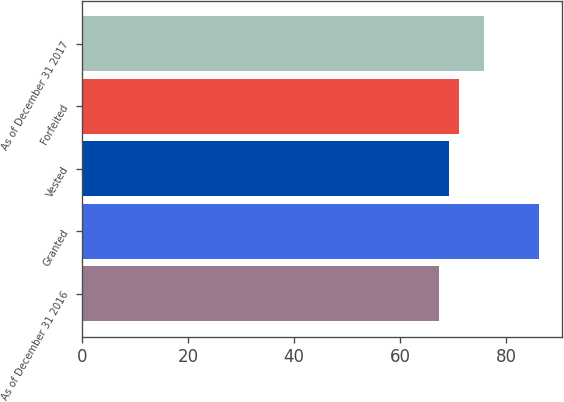Convert chart to OTSL. <chart><loc_0><loc_0><loc_500><loc_500><bar_chart><fcel>As of December 31 2016<fcel>Granted<fcel>Vested<fcel>Forfeited<fcel>As of December 31 2017<nl><fcel>67.42<fcel>86.2<fcel>69.3<fcel>71.18<fcel>75.75<nl></chart> 